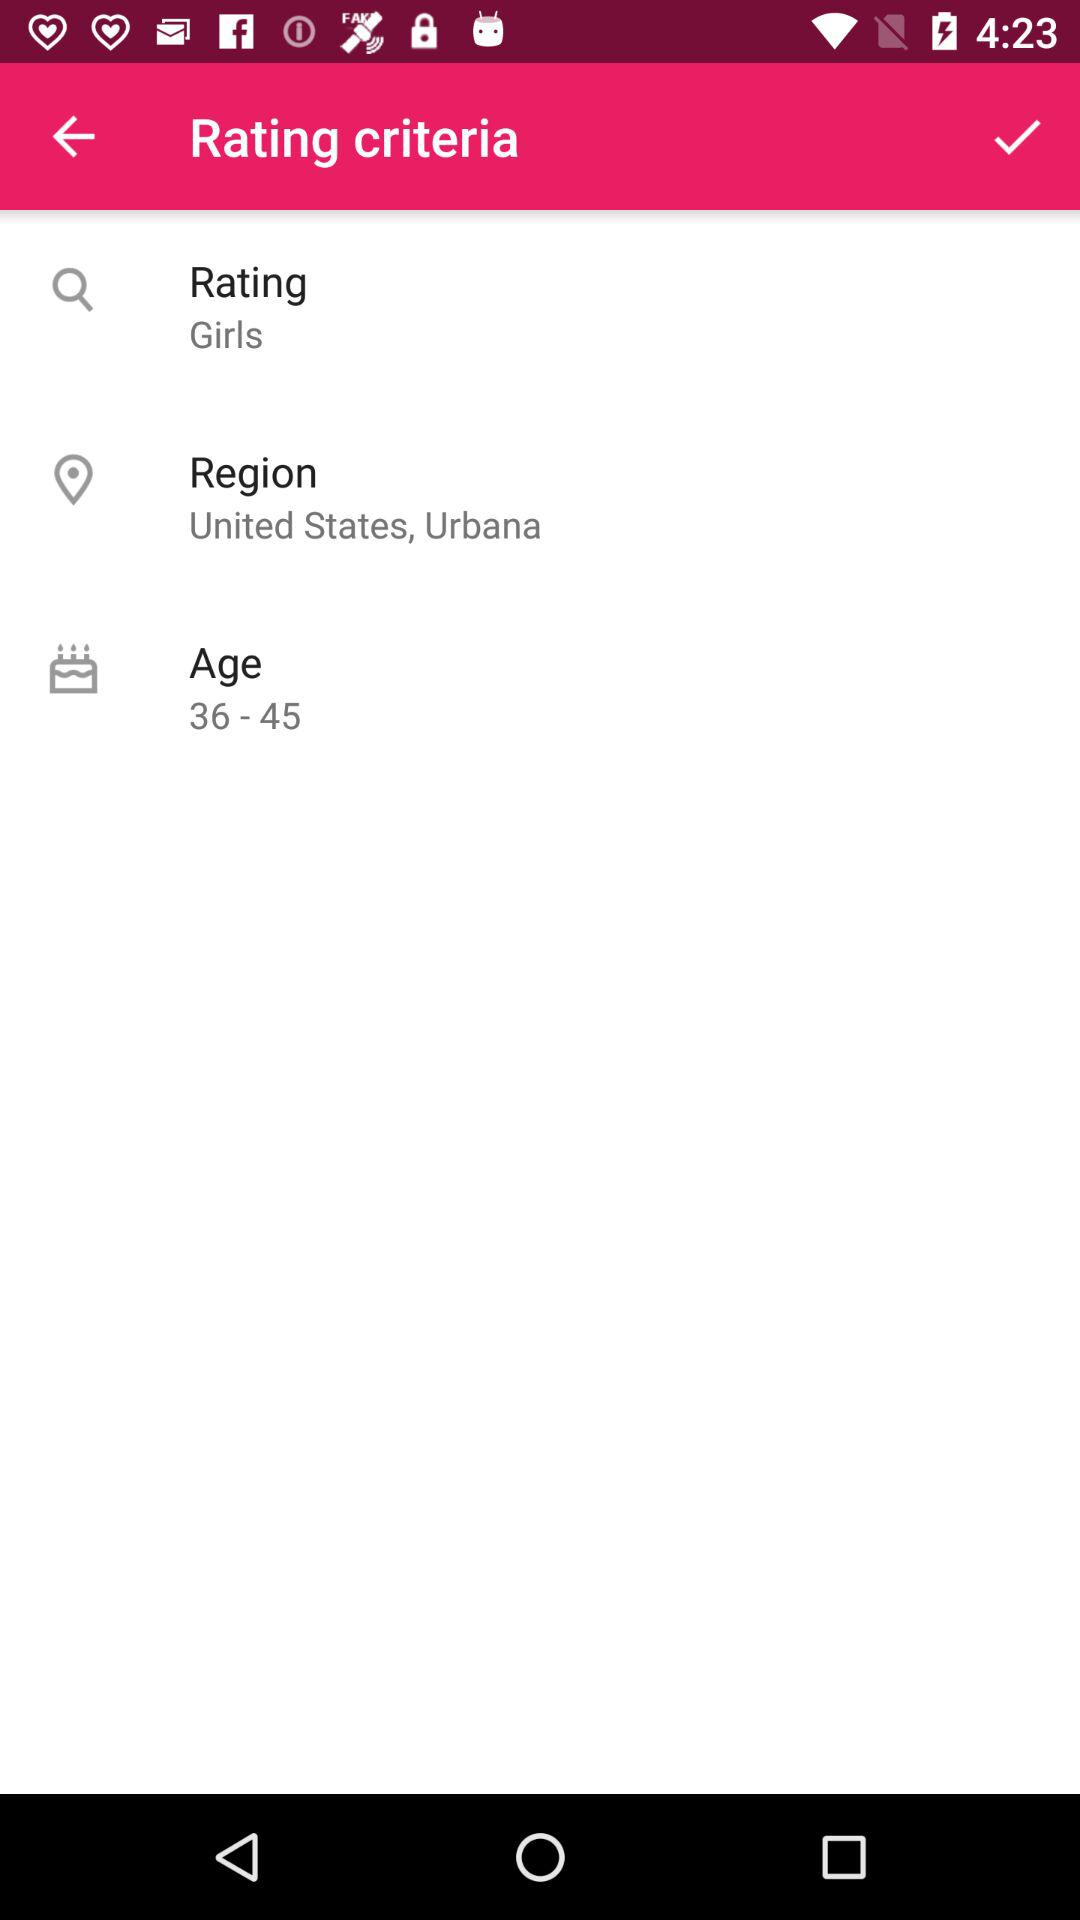Can you provide more details on the user interface design? The user interface shown in the image is minimalistic with a pink header suggestive of a feminine-oriented design. The three criteria are clearly listed for easy readability, with icons indicating search, location and age categories. The checkmark in the header implies a selection or confirmation action is available, and the interface design suggests a mobile application. 